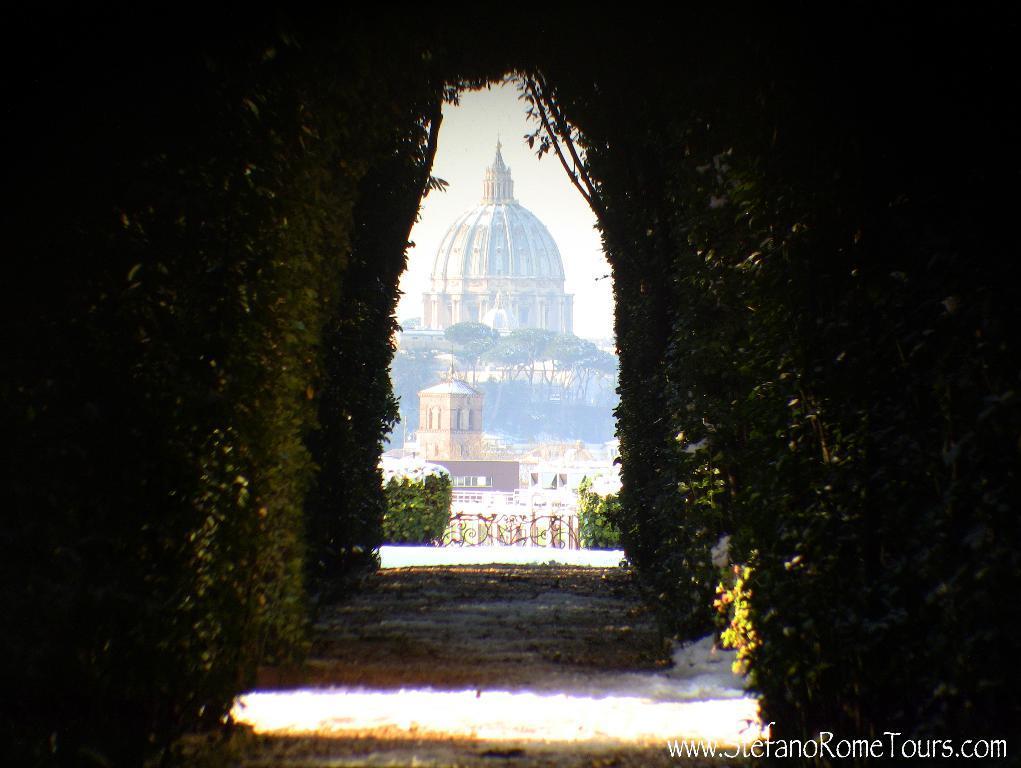How would you summarize this image in a sentence or two? In the foreground of the picture we can see a walk way and plants. In the middle of the picture we can see trees, buildings, railing and plants. In the background we can see a dome of a building. At the top it is sky. 